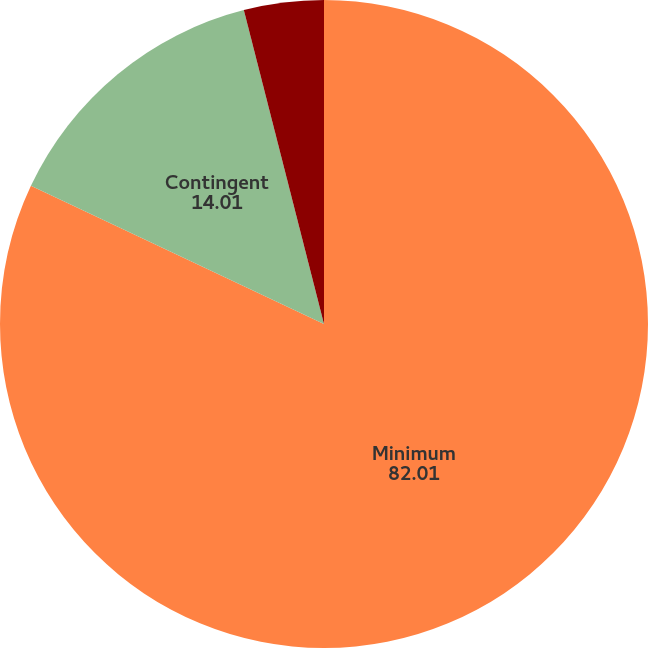Convert chart to OTSL. <chart><loc_0><loc_0><loc_500><loc_500><pie_chart><fcel>Minimum<fcel>Contingent<fcel>Minimum rental income<nl><fcel>82.01%<fcel>14.01%<fcel>3.98%<nl></chart> 